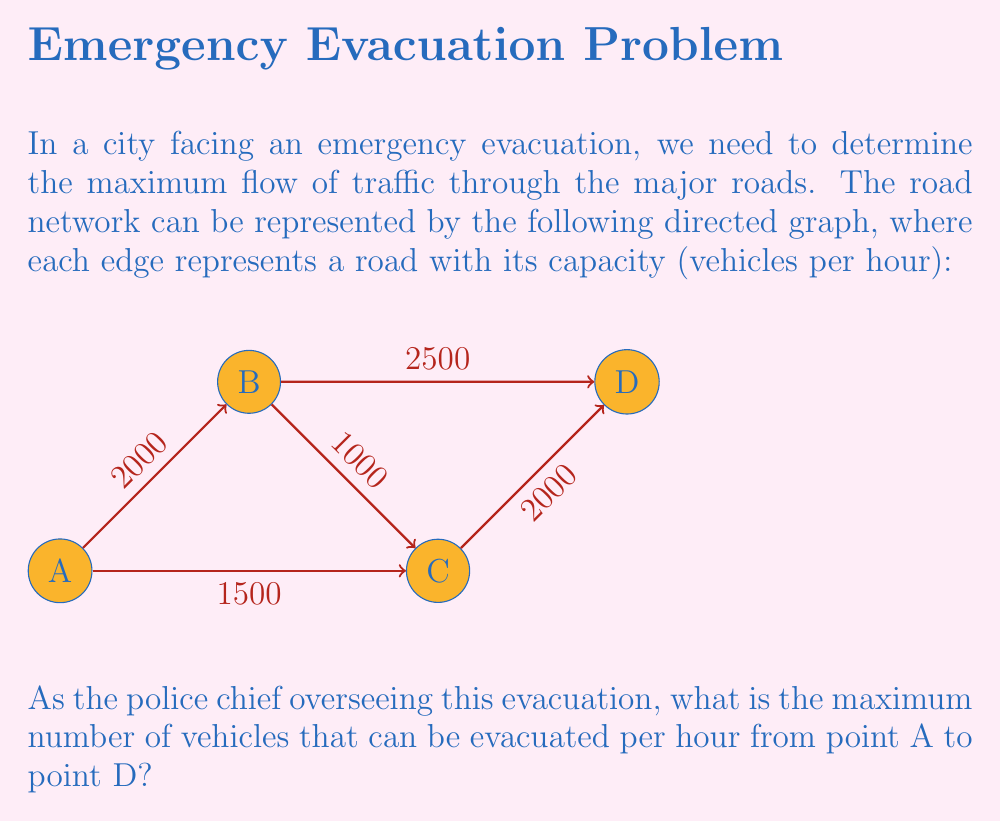Provide a solution to this math problem. To solve this problem, we'll use the Ford-Fulkerson algorithm to find the maximum flow in the network. Here's a step-by-step explanation:

1) First, we need to identify all possible paths from A to D:
   Path 1: A → B → D
   Path 2: A → C → D
   Path 3: A → B → C → D

2) We'll start with zero flow and incrementally increase it along augmenting paths:

3) Iteration 1: Use path A → B → D
   Min capacity = min(2000, 2500) = 2000
   Flow becomes: 2000

4) Iteration 2: Use path A → C → D
   Min capacity = min(1500, 2000) = 1500
   Flow becomes: 2000 + 1500 = 3500

5) Iteration 3: Use path A → B → C → D
   Residual capacities:
   A → B: 2000 - 2000 = 0
   B → C: 1000
   C → D: 2000 - 1500 = 500
   Min capacity = min(0, 1000, 500) = 0

6) No more augmenting paths are available, so the algorithm terminates.

The maximum flow from A to D is thus 3500 vehicles per hour.

This solution ensures that we're utilizing the major roads to their full capacity during the evacuation, which is crucial for efficient crisis management.
Answer: 3500 vehicles per hour 